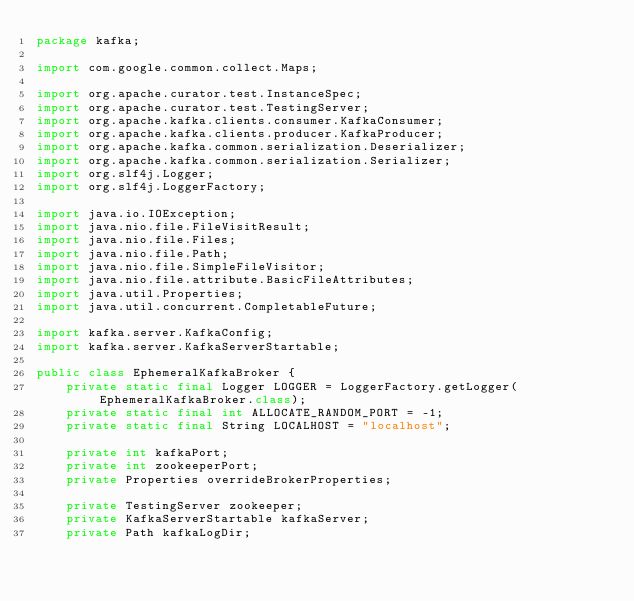Convert code to text. <code><loc_0><loc_0><loc_500><loc_500><_Java_>package kafka;

import com.google.common.collect.Maps;

import org.apache.curator.test.InstanceSpec;
import org.apache.curator.test.TestingServer;
import org.apache.kafka.clients.consumer.KafkaConsumer;
import org.apache.kafka.clients.producer.KafkaProducer;
import org.apache.kafka.common.serialization.Deserializer;
import org.apache.kafka.common.serialization.Serializer;
import org.slf4j.Logger;
import org.slf4j.LoggerFactory;

import java.io.IOException;
import java.nio.file.FileVisitResult;
import java.nio.file.Files;
import java.nio.file.Path;
import java.nio.file.SimpleFileVisitor;
import java.nio.file.attribute.BasicFileAttributes;
import java.util.Properties;
import java.util.concurrent.CompletableFuture;

import kafka.server.KafkaConfig;
import kafka.server.KafkaServerStartable;

public class EphemeralKafkaBroker {
    private static final Logger LOGGER = LoggerFactory.getLogger(EphemeralKafkaBroker.class);
    private static final int ALLOCATE_RANDOM_PORT = -1;
    private static final String LOCALHOST = "localhost";

    private int kafkaPort;
    private int zookeeperPort;
    private Properties overrideBrokerProperties;

    private TestingServer zookeeper;
    private KafkaServerStartable kafkaServer;
    private Path kafkaLogDir;
</code> 